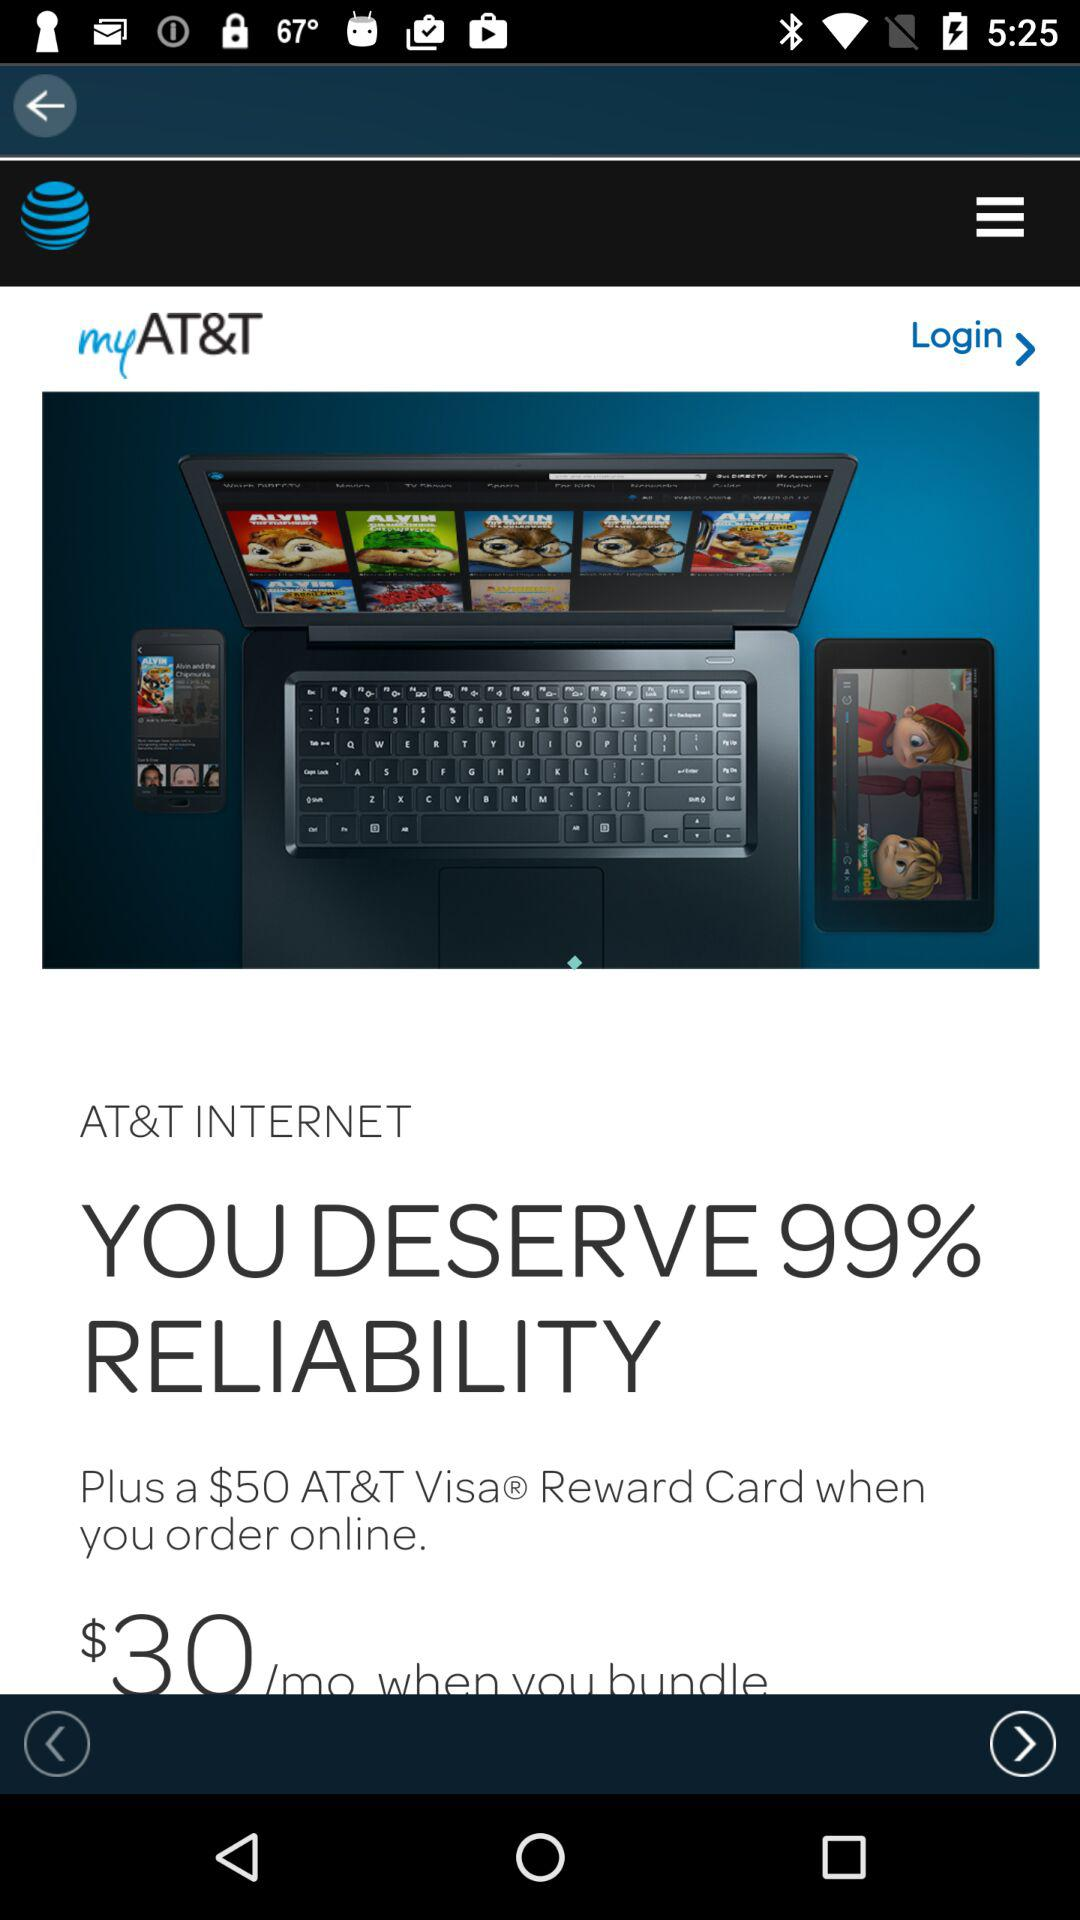How much reliability does the user deserve? The user deserves 99% reliability. 